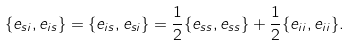Convert formula to latex. <formula><loc_0><loc_0><loc_500><loc_500>\{ e _ { s i } , e _ { i s } \} = \{ e _ { i s } , e _ { s i } \} = \frac { 1 } { 2 } \{ e _ { s s } , e _ { s s } \} + \frac { 1 } { 2 } \{ e _ { i i } , e _ { i i } \} .</formula> 